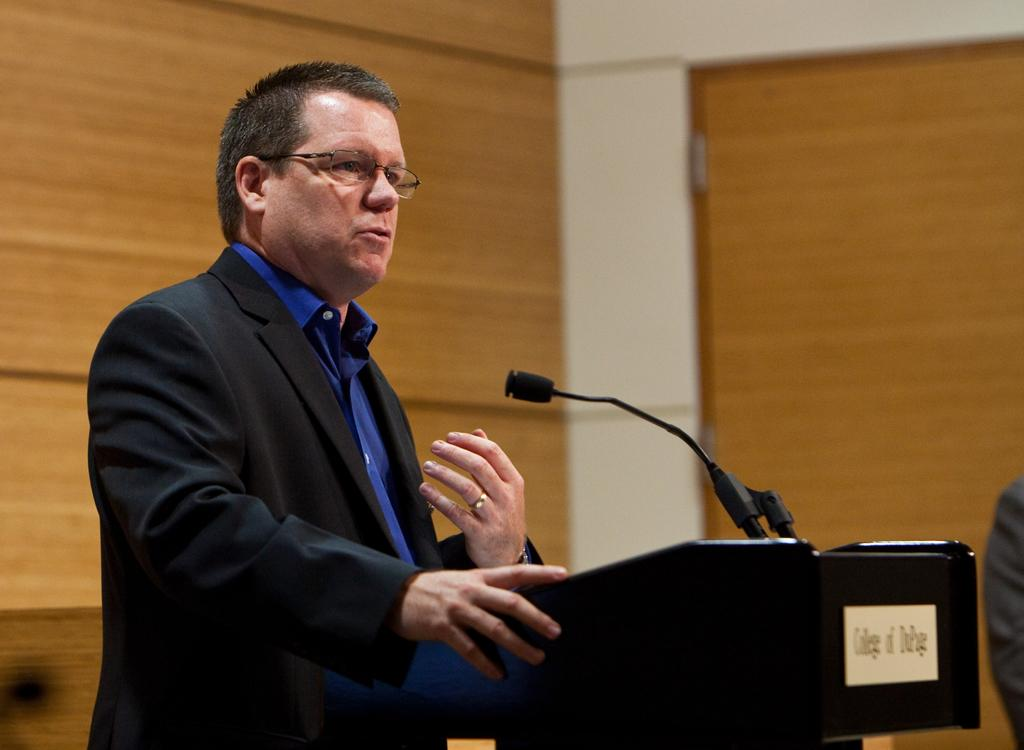What is the person in the image doing near the podium? The person is standing near the podium. What can be seen in the background of the image? There is a wooden wall in the background of the image. Are there any architectural features in the image? Yes, there is a pillar in the image. Can you see the person's dad in the image? There is no information about the person's dad in the image, so it cannot be determined if they are present. 